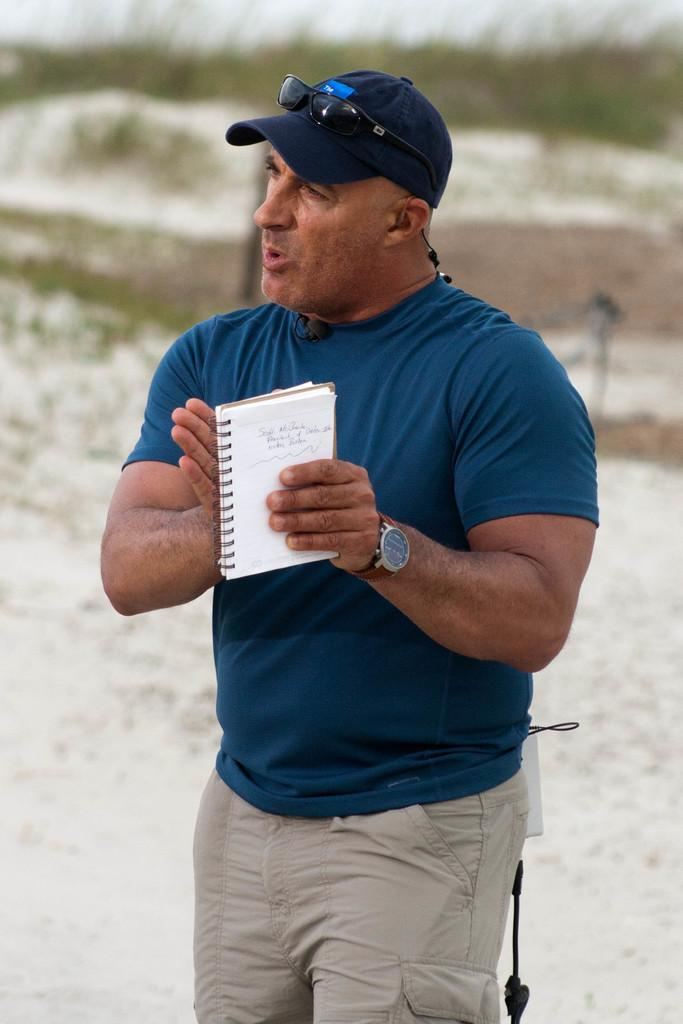What is the person in the image doing? The person is holding a book and talking. What is the person wearing on their head? The person is wearing a cap. Are there any accessories visible in the image? Yes, there are goggles visible in the image. What can be seen in the background of the image? The background has a blurred view. What type of vegetation is present in the image? There are plants in the image. What type of carpenter tools can be seen in the image? There are no carpenter tools present in the image. What question is the person answering in the image? The image does not show the person answering a specific question. 